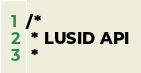<code> <loc_0><loc_0><loc_500><loc_500><_C#_>/* 
 * LUSID API
 *</code> 